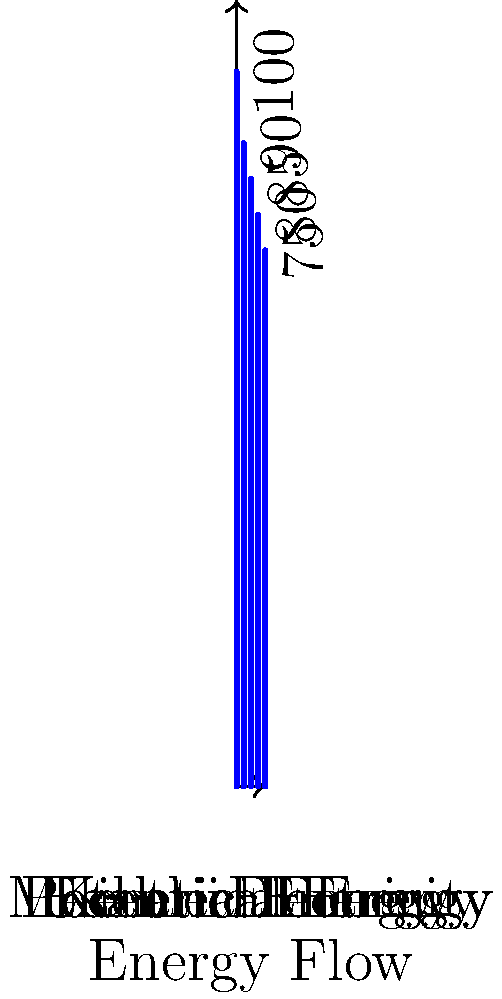The energy flow chart above represents the energy transformations in a hydroelectric power plant. If the initial potential energy is 100%, what percentage of energy is lost as heat and other forms during the conversion process from mechanical energy to electrical energy? To solve this problem, we need to follow these steps:

1. Identify the relevant energy values from the chart:
   - Mechanical Energy: 85%
   - Electrical Energy: 80%

2. Calculate the energy lost during the conversion:
   $$\text{Energy lost} = \text{Mechanical Energy} - \text{Electrical Energy}$$
   $$\text{Energy lost} = 85\% - 80\% = 5\%$$

3. Express the result as a percentage of the initial energy:
   The initial potential energy is 100%, so the 5% loss is already expressed as a percentage of the initial energy.

Therefore, 5% of the initial energy is lost as heat and other forms during the conversion from mechanical energy to electrical energy in this hydroelectric power plant system.
Answer: 5% 